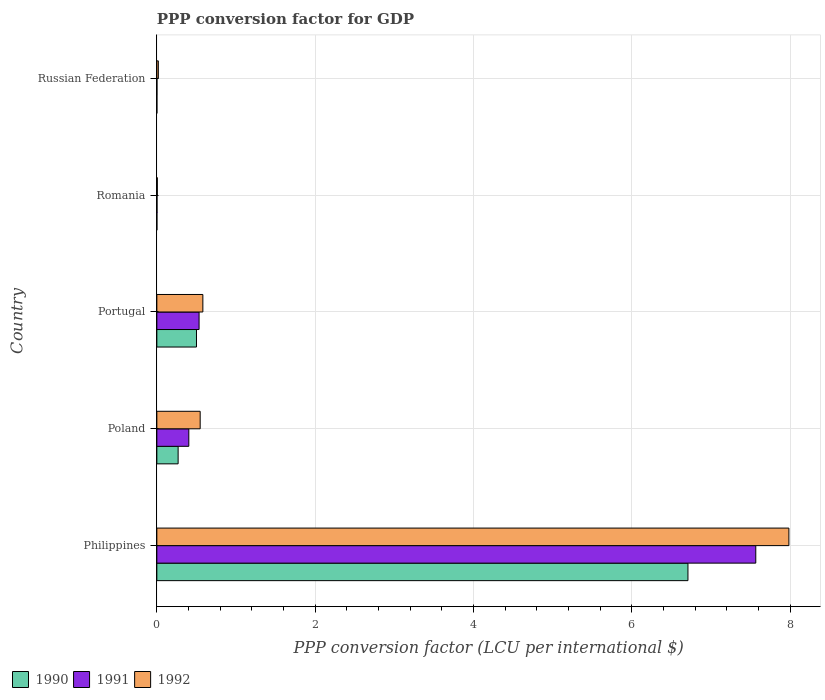How many bars are there on the 1st tick from the top?
Provide a succinct answer. 3. How many bars are there on the 4th tick from the bottom?
Your answer should be very brief. 3. What is the label of the 3rd group of bars from the top?
Provide a short and direct response. Portugal. In how many cases, is the number of bars for a given country not equal to the number of legend labels?
Offer a very short reply. 0. What is the PPP conversion factor for GDP in 1992 in Poland?
Provide a succinct answer. 0.55. Across all countries, what is the maximum PPP conversion factor for GDP in 1992?
Provide a short and direct response. 7.98. Across all countries, what is the minimum PPP conversion factor for GDP in 1992?
Offer a very short reply. 0.01. In which country was the PPP conversion factor for GDP in 1990 maximum?
Your response must be concise. Philippines. In which country was the PPP conversion factor for GDP in 1991 minimum?
Make the answer very short. Russian Federation. What is the total PPP conversion factor for GDP in 1990 in the graph?
Keep it short and to the point. 7.48. What is the difference between the PPP conversion factor for GDP in 1992 in Philippines and that in Russian Federation?
Make the answer very short. 7.97. What is the difference between the PPP conversion factor for GDP in 1992 in Russian Federation and the PPP conversion factor for GDP in 1991 in Philippines?
Your answer should be very brief. -7.55. What is the average PPP conversion factor for GDP in 1990 per country?
Your answer should be compact. 1.5. What is the difference between the PPP conversion factor for GDP in 1991 and PPP conversion factor for GDP in 1992 in Poland?
Offer a terse response. -0.14. In how many countries, is the PPP conversion factor for GDP in 1991 greater than 1.2000000000000002 LCU?
Offer a very short reply. 1. What is the ratio of the PPP conversion factor for GDP in 1992 in Philippines to that in Russian Federation?
Provide a short and direct response. 428.04. Is the difference between the PPP conversion factor for GDP in 1991 in Philippines and Portugal greater than the difference between the PPP conversion factor for GDP in 1992 in Philippines and Portugal?
Your response must be concise. No. What is the difference between the highest and the second highest PPP conversion factor for GDP in 1990?
Your answer should be compact. 6.21. What is the difference between the highest and the lowest PPP conversion factor for GDP in 1991?
Make the answer very short. 7.56. What does the 2nd bar from the top in Russian Federation represents?
Provide a succinct answer. 1991. What does the 2nd bar from the bottom in Romania represents?
Your answer should be compact. 1991. Are all the bars in the graph horizontal?
Provide a short and direct response. Yes. How many countries are there in the graph?
Your response must be concise. 5. What is the difference between two consecutive major ticks on the X-axis?
Your answer should be compact. 2. Are the values on the major ticks of X-axis written in scientific E-notation?
Ensure brevity in your answer.  No. Where does the legend appear in the graph?
Provide a succinct answer. Bottom left. How many legend labels are there?
Provide a short and direct response. 3. What is the title of the graph?
Give a very brief answer. PPP conversion factor for GDP. Does "1973" appear as one of the legend labels in the graph?
Make the answer very short. No. What is the label or title of the X-axis?
Give a very brief answer. PPP conversion factor (LCU per international $). What is the label or title of the Y-axis?
Offer a very short reply. Country. What is the PPP conversion factor (LCU per international $) in 1990 in Philippines?
Provide a succinct answer. 6.71. What is the PPP conversion factor (LCU per international $) in 1991 in Philippines?
Keep it short and to the point. 7.57. What is the PPP conversion factor (LCU per international $) of 1992 in Philippines?
Your answer should be compact. 7.98. What is the PPP conversion factor (LCU per international $) in 1990 in Poland?
Your answer should be very brief. 0.27. What is the PPP conversion factor (LCU per international $) in 1991 in Poland?
Offer a very short reply. 0.4. What is the PPP conversion factor (LCU per international $) of 1992 in Poland?
Make the answer very short. 0.55. What is the PPP conversion factor (LCU per international $) of 1990 in Portugal?
Ensure brevity in your answer.  0.5. What is the PPP conversion factor (LCU per international $) of 1991 in Portugal?
Ensure brevity in your answer.  0.53. What is the PPP conversion factor (LCU per international $) of 1992 in Portugal?
Your answer should be compact. 0.58. What is the PPP conversion factor (LCU per international $) of 1990 in Romania?
Your answer should be very brief. 0. What is the PPP conversion factor (LCU per international $) of 1991 in Romania?
Provide a short and direct response. 0. What is the PPP conversion factor (LCU per international $) in 1992 in Romania?
Your answer should be very brief. 0.01. What is the PPP conversion factor (LCU per international $) in 1990 in Russian Federation?
Your answer should be very brief. 0. What is the PPP conversion factor (LCU per international $) of 1991 in Russian Federation?
Give a very brief answer. 0. What is the PPP conversion factor (LCU per international $) in 1992 in Russian Federation?
Offer a very short reply. 0.02. Across all countries, what is the maximum PPP conversion factor (LCU per international $) of 1990?
Your answer should be very brief. 6.71. Across all countries, what is the maximum PPP conversion factor (LCU per international $) in 1991?
Provide a short and direct response. 7.57. Across all countries, what is the maximum PPP conversion factor (LCU per international $) of 1992?
Offer a terse response. 7.98. Across all countries, what is the minimum PPP conversion factor (LCU per international $) of 1990?
Provide a succinct answer. 0. Across all countries, what is the minimum PPP conversion factor (LCU per international $) of 1991?
Make the answer very short. 0. Across all countries, what is the minimum PPP conversion factor (LCU per international $) of 1992?
Ensure brevity in your answer.  0.01. What is the total PPP conversion factor (LCU per international $) of 1990 in the graph?
Offer a very short reply. 7.48. What is the total PPP conversion factor (LCU per international $) of 1991 in the graph?
Your answer should be compact. 8.51. What is the total PPP conversion factor (LCU per international $) in 1992 in the graph?
Offer a terse response. 9.14. What is the difference between the PPP conversion factor (LCU per international $) in 1990 in Philippines and that in Poland?
Your response must be concise. 6.44. What is the difference between the PPP conversion factor (LCU per international $) of 1991 in Philippines and that in Poland?
Ensure brevity in your answer.  7.16. What is the difference between the PPP conversion factor (LCU per international $) in 1992 in Philippines and that in Poland?
Your answer should be compact. 7.44. What is the difference between the PPP conversion factor (LCU per international $) of 1990 in Philippines and that in Portugal?
Offer a very short reply. 6.21. What is the difference between the PPP conversion factor (LCU per international $) in 1991 in Philippines and that in Portugal?
Provide a succinct answer. 7.03. What is the difference between the PPP conversion factor (LCU per international $) of 1992 in Philippines and that in Portugal?
Offer a terse response. 7.4. What is the difference between the PPP conversion factor (LCU per international $) of 1990 in Philippines and that in Romania?
Keep it short and to the point. 6.71. What is the difference between the PPP conversion factor (LCU per international $) in 1991 in Philippines and that in Romania?
Keep it short and to the point. 7.56. What is the difference between the PPP conversion factor (LCU per international $) in 1992 in Philippines and that in Romania?
Your answer should be compact. 7.98. What is the difference between the PPP conversion factor (LCU per international $) in 1990 in Philippines and that in Russian Federation?
Provide a succinct answer. 6.71. What is the difference between the PPP conversion factor (LCU per international $) in 1991 in Philippines and that in Russian Federation?
Provide a succinct answer. 7.56. What is the difference between the PPP conversion factor (LCU per international $) in 1992 in Philippines and that in Russian Federation?
Offer a terse response. 7.97. What is the difference between the PPP conversion factor (LCU per international $) in 1990 in Poland and that in Portugal?
Your answer should be very brief. -0.23. What is the difference between the PPP conversion factor (LCU per international $) of 1991 in Poland and that in Portugal?
Your response must be concise. -0.13. What is the difference between the PPP conversion factor (LCU per international $) of 1992 in Poland and that in Portugal?
Provide a succinct answer. -0.03. What is the difference between the PPP conversion factor (LCU per international $) of 1990 in Poland and that in Romania?
Your answer should be compact. 0.27. What is the difference between the PPP conversion factor (LCU per international $) of 1991 in Poland and that in Romania?
Keep it short and to the point. 0.4. What is the difference between the PPP conversion factor (LCU per international $) of 1992 in Poland and that in Romania?
Provide a succinct answer. 0.54. What is the difference between the PPP conversion factor (LCU per international $) of 1990 in Poland and that in Russian Federation?
Your answer should be compact. 0.27. What is the difference between the PPP conversion factor (LCU per international $) in 1991 in Poland and that in Russian Federation?
Make the answer very short. 0.4. What is the difference between the PPP conversion factor (LCU per international $) of 1992 in Poland and that in Russian Federation?
Ensure brevity in your answer.  0.53. What is the difference between the PPP conversion factor (LCU per international $) of 1990 in Portugal and that in Romania?
Make the answer very short. 0.5. What is the difference between the PPP conversion factor (LCU per international $) of 1991 in Portugal and that in Romania?
Your answer should be compact. 0.53. What is the difference between the PPP conversion factor (LCU per international $) of 1992 in Portugal and that in Romania?
Provide a short and direct response. 0.58. What is the difference between the PPP conversion factor (LCU per international $) of 1990 in Portugal and that in Russian Federation?
Your answer should be very brief. 0.5. What is the difference between the PPP conversion factor (LCU per international $) in 1991 in Portugal and that in Russian Federation?
Offer a very short reply. 0.53. What is the difference between the PPP conversion factor (LCU per international $) of 1992 in Portugal and that in Russian Federation?
Ensure brevity in your answer.  0.56. What is the difference between the PPP conversion factor (LCU per international $) of 1991 in Romania and that in Russian Federation?
Offer a terse response. 0. What is the difference between the PPP conversion factor (LCU per international $) of 1992 in Romania and that in Russian Federation?
Offer a terse response. -0.01. What is the difference between the PPP conversion factor (LCU per international $) of 1990 in Philippines and the PPP conversion factor (LCU per international $) of 1991 in Poland?
Your answer should be compact. 6.31. What is the difference between the PPP conversion factor (LCU per international $) of 1990 in Philippines and the PPP conversion factor (LCU per international $) of 1992 in Poland?
Keep it short and to the point. 6.16. What is the difference between the PPP conversion factor (LCU per international $) in 1991 in Philippines and the PPP conversion factor (LCU per international $) in 1992 in Poland?
Keep it short and to the point. 7.02. What is the difference between the PPP conversion factor (LCU per international $) in 1990 in Philippines and the PPP conversion factor (LCU per international $) in 1991 in Portugal?
Offer a very short reply. 6.18. What is the difference between the PPP conversion factor (LCU per international $) in 1990 in Philippines and the PPP conversion factor (LCU per international $) in 1992 in Portugal?
Provide a succinct answer. 6.13. What is the difference between the PPP conversion factor (LCU per international $) in 1991 in Philippines and the PPP conversion factor (LCU per international $) in 1992 in Portugal?
Ensure brevity in your answer.  6.98. What is the difference between the PPP conversion factor (LCU per international $) of 1990 in Philippines and the PPP conversion factor (LCU per international $) of 1991 in Romania?
Offer a terse response. 6.71. What is the difference between the PPP conversion factor (LCU per international $) of 1990 in Philippines and the PPP conversion factor (LCU per international $) of 1992 in Romania?
Offer a terse response. 6.7. What is the difference between the PPP conversion factor (LCU per international $) in 1991 in Philippines and the PPP conversion factor (LCU per international $) in 1992 in Romania?
Offer a very short reply. 7.56. What is the difference between the PPP conversion factor (LCU per international $) in 1990 in Philippines and the PPP conversion factor (LCU per international $) in 1991 in Russian Federation?
Ensure brevity in your answer.  6.71. What is the difference between the PPP conversion factor (LCU per international $) of 1990 in Philippines and the PPP conversion factor (LCU per international $) of 1992 in Russian Federation?
Ensure brevity in your answer.  6.69. What is the difference between the PPP conversion factor (LCU per international $) of 1991 in Philippines and the PPP conversion factor (LCU per international $) of 1992 in Russian Federation?
Give a very brief answer. 7.55. What is the difference between the PPP conversion factor (LCU per international $) in 1990 in Poland and the PPP conversion factor (LCU per international $) in 1991 in Portugal?
Your response must be concise. -0.26. What is the difference between the PPP conversion factor (LCU per international $) of 1990 in Poland and the PPP conversion factor (LCU per international $) of 1992 in Portugal?
Keep it short and to the point. -0.31. What is the difference between the PPP conversion factor (LCU per international $) of 1991 in Poland and the PPP conversion factor (LCU per international $) of 1992 in Portugal?
Your answer should be very brief. -0.18. What is the difference between the PPP conversion factor (LCU per international $) of 1990 in Poland and the PPP conversion factor (LCU per international $) of 1991 in Romania?
Provide a succinct answer. 0.27. What is the difference between the PPP conversion factor (LCU per international $) of 1990 in Poland and the PPP conversion factor (LCU per international $) of 1992 in Romania?
Ensure brevity in your answer.  0.26. What is the difference between the PPP conversion factor (LCU per international $) in 1991 in Poland and the PPP conversion factor (LCU per international $) in 1992 in Romania?
Provide a short and direct response. 0.4. What is the difference between the PPP conversion factor (LCU per international $) in 1990 in Poland and the PPP conversion factor (LCU per international $) in 1991 in Russian Federation?
Give a very brief answer. 0.27. What is the difference between the PPP conversion factor (LCU per international $) of 1990 in Poland and the PPP conversion factor (LCU per international $) of 1992 in Russian Federation?
Provide a succinct answer. 0.25. What is the difference between the PPP conversion factor (LCU per international $) of 1991 in Poland and the PPP conversion factor (LCU per international $) of 1992 in Russian Federation?
Make the answer very short. 0.39. What is the difference between the PPP conversion factor (LCU per international $) of 1990 in Portugal and the PPP conversion factor (LCU per international $) of 1991 in Romania?
Give a very brief answer. 0.5. What is the difference between the PPP conversion factor (LCU per international $) in 1990 in Portugal and the PPP conversion factor (LCU per international $) in 1992 in Romania?
Your answer should be compact. 0.49. What is the difference between the PPP conversion factor (LCU per international $) in 1991 in Portugal and the PPP conversion factor (LCU per international $) in 1992 in Romania?
Provide a short and direct response. 0.53. What is the difference between the PPP conversion factor (LCU per international $) in 1990 in Portugal and the PPP conversion factor (LCU per international $) in 1991 in Russian Federation?
Provide a short and direct response. 0.5. What is the difference between the PPP conversion factor (LCU per international $) in 1990 in Portugal and the PPP conversion factor (LCU per international $) in 1992 in Russian Federation?
Your answer should be compact. 0.48. What is the difference between the PPP conversion factor (LCU per international $) in 1991 in Portugal and the PPP conversion factor (LCU per international $) in 1992 in Russian Federation?
Keep it short and to the point. 0.51. What is the difference between the PPP conversion factor (LCU per international $) of 1990 in Romania and the PPP conversion factor (LCU per international $) of 1991 in Russian Federation?
Provide a succinct answer. -0. What is the difference between the PPP conversion factor (LCU per international $) in 1990 in Romania and the PPP conversion factor (LCU per international $) in 1992 in Russian Federation?
Keep it short and to the point. -0.02. What is the difference between the PPP conversion factor (LCU per international $) in 1991 in Romania and the PPP conversion factor (LCU per international $) in 1992 in Russian Federation?
Provide a short and direct response. -0.02. What is the average PPP conversion factor (LCU per international $) in 1990 per country?
Provide a succinct answer. 1.5. What is the average PPP conversion factor (LCU per international $) in 1991 per country?
Offer a very short reply. 1.7. What is the average PPP conversion factor (LCU per international $) of 1992 per country?
Make the answer very short. 1.83. What is the difference between the PPP conversion factor (LCU per international $) of 1990 and PPP conversion factor (LCU per international $) of 1991 in Philippines?
Your answer should be compact. -0.86. What is the difference between the PPP conversion factor (LCU per international $) in 1990 and PPP conversion factor (LCU per international $) in 1992 in Philippines?
Offer a very short reply. -1.28. What is the difference between the PPP conversion factor (LCU per international $) of 1991 and PPP conversion factor (LCU per international $) of 1992 in Philippines?
Offer a very short reply. -0.42. What is the difference between the PPP conversion factor (LCU per international $) of 1990 and PPP conversion factor (LCU per international $) of 1991 in Poland?
Your response must be concise. -0.14. What is the difference between the PPP conversion factor (LCU per international $) of 1990 and PPP conversion factor (LCU per international $) of 1992 in Poland?
Ensure brevity in your answer.  -0.28. What is the difference between the PPP conversion factor (LCU per international $) in 1991 and PPP conversion factor (LCU per international $) in 1992 in Poland?
Offer a terse response. -0.14. What is the difference between the PPP conversion factor (LCU per international $) of 1990 and PPP conversion factor (LCU per international $) of 1991 in Portugal?
Your answer should be very brief. -0.03. What is the difference between the PPP conversion factor (LCU per international $) in 1990 and PPP conversion factor (LCU per international $) in 1992 in Portugal?
Your answer should be compact. -0.08. What is the difference between the PPP conversion factor (LCU per international $) of 1991 and PPP conversion factor (LCU per international $) of 1992 in Portugal?
Your answer should be compact. -0.05. What is the difference between the PPP conversion factor (LCU per international $) in 1990 and PPP conversion factor (LCU per international $) in 1991 in Romania?
Make the answer very short. -0. What is the difference between the PPP conversion factor (LCU per international $) in 1990 and PPP conversion factor (LCU per international $) in 1992 in Romania?
Offer a terse response. -0.01. What is the difference between the PPP conversion factor (LCU per international $) in 1991 and PPP conversion factor (LCU per international $) in 1992 in Romania?
Provide a succinct answer. -0. What is the difference between the PPP conversion factor (LCU per international $) in 1990 and PPP conversion factor (LCU per international $) in 1991 in Russian Federation?
Your answer should be very brief. -0. What is the difference between the PPP conversion factor (LCU per international $) of 1990 and PPP conversion factor (LCU per international $) of 1992 in Russian Federation?
Your response must be concise. -0.02. What is the difference between the PPP conversion factor (LCU per international $) of 1991 and PPP conversion factor (LCU per international $) of 1992 in Russian Federation?
Keep it short and to the point. -0.02. What is the ratio of the PPP conversion factor (LCU per international $) of 1990 in Philippines to that in Poland?
Make the answer very short. 24.97. What is the ratio of the PPP conversion factor (LCU per international $) of 1991 in Philippines to that in Poland?
Your response must be concise. 18.74. What is the ratio of the PPP conversion factor (LCU per international $) of 1992 in Philippines to that in Poland?
Offer a terse response. 14.59. What is the ratio of the PPP conversion factor (LCU per international $) in 1990 in Philippines to that in Portugal?
Your answer should be compact. 13.4. What is the ratio of the PPP conversion factor (LCU per international $) in 1991 in Philippines to that in Portugal?
Provide a short and direct response. 14.18. What is the ratio of the PPP conversion factor (LCU per international $) in 1992 in Philippines to that in Portugal?
Your answer should be very brief. 13.74. What is the ratio of the PPP conversion factor (LCU per international $) in 1990 in Philippines to that in Romania?
Your response must be concise. 9420.54. What is the ratio of the PPP conversion factor (LCU per international $) of 1991 in Philippines to that in Romania?
Offer a very short reply. 3721.12. What is the ratio of the PPP conversion factor (LCU per international $) in 1992 in Philippines to that in Romania?
Ensure brevity in your answer.  1339.4. What is the ratio of the PPP conversion factor (LCU per international $) of 1990 in Philippines to that in Russian Federation?
Give a very brief answer. 1.24e+04. What is the ratio of the PPP conversion factor (LCU per international $) of 1991 in Philippines to that in Russian Federation?
Ensure brevity in your answer.  6307.26. What is the ratio of the PPP conversion factor (LCU per international $) in 1992 in Philippines to that in Russian Federation?
Your answer should be compact. 428.04. What is the ratio of the PPP conversion factor (LCU per international $) in 1990 in Poland to that in Portugal?
Your answer should be compact. 0.54. What is the ratio of the PPP conversion factor (LCU per international $) of 1991 in Poland to that in Portugal?
Make the answer very short. 0.76. What is the ratio of the PPP conversion factor (LCU per international $) of 1992 in Poland to that in Portugal?
Provide a succinct answer. 0.94. What is the ratio of the PPP conversion factor (LCU per international $) of 1990 in Poland to that in Romania?
Make the answer very short. 377.33. What is the ratio of the PPP conversion factor (LCU per international $) of 1991 in Poland to that in Romania?
Your answer should be compact. 198.58. What is the ratio of the PPP conversion factor (LCU per international $) in 1992 in Poland to that in Romania?
Your answer should be compact. 91.81. What is the ratio of the PPP conversion factor (LCU per international $) of 1990 in Poland to that in Russian Federation?
Provide a succinct answer. 495.68. What is the ratio of the PPP conversion factor (LCU per international $) in 1991 in Poland to that in Russian Federation?
Your answer should be very brief. 336.6. What is the ratio of the PPP conversion factor (LCU per international $) in 1992 in Poland to that in Russian Federation?
Provide a succinct answer. 29.34. What is the ratio of the PPP conversion factor (LCU per international $) of 1990 in Portugal to that in Romania?
Ensure brevity in your answer.  703.1. What is the ratio of the PPP conversion factor (LCU per international $) of 1991 in Portugal to that in Romania?
Offer a terse response. 262.37. What is the ratio of the PPP conversion factor (LCU per international $) of 1992 in Portugal to that in Romania?
Provide a succinct answer. 97.51. What is the ratio of the PPP conversion factor (LCU per international $) of 1990 in Portugal to that in Russian Federation?
Your answer should be very brief. 923.6. What is the ratio of the PPP conversion factor (LCU per international $) in 1991 in Portugal to that in Russian Federation?
Give a very brief answer. 444.72. What is the ratio of the PPP conversion factor (LCU per international $) in 1992 in Portugal to that in Russian Federation?
Keep it short and to the point. 31.16. What is the ratio of the PPP conversion factor (LCU per international $) of 1990 in Romania to that in Russian Federation?
Ensure brevity in your answer.  1.31. What is the ratio of the PPP conversion factor (LCU per international $) of 1991 in Romania to that in Russian Federation?
Provide a short and direct response. 1.7. What is the ratio of the PPP conversion factor (LCU per international $) in 1992 in Romania to that in Russian Federation?
Your answer should be compact. 0.32. What is the difference between the highest and the second highest PPP conversion factor (LCU per international $) in 1990?
Give a very brief answer. 6.21. What is the difference between the highest and the second highest PPP conversion factor (LCU per international $) in 1991?
Offer a very short reply. 7.03. What is the difference between the highest and the second highest PPP conversion factor (LCU per international $) of 1992?
Your answer should be very brief. 7.4. What is the difference between the highest and the lowest PPP conversion factor (LCU per international $) of 1990?
Provide a short and direct response. 6.71. What is the difference between the highest and the lowest PPP conversion factor (LCU per international $) in 1991?
Keep it short and to the point. 7.56. What is the difference between the highest and the lowest PPP conversion factor (LCU per international $) of 1992?
Your answer should be compact. 7.98. 